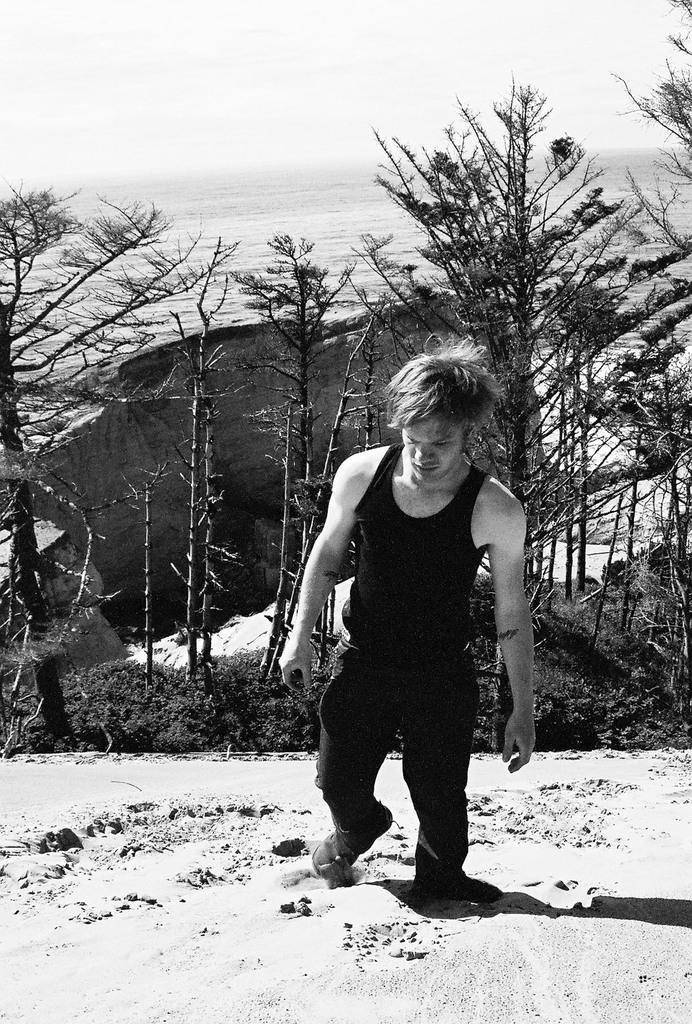Could you give a brief overview of what you see in this image? In this image I can see the person standing on the snow. To the back of the person I can see many trees and the sky. And this is a black and white image. 